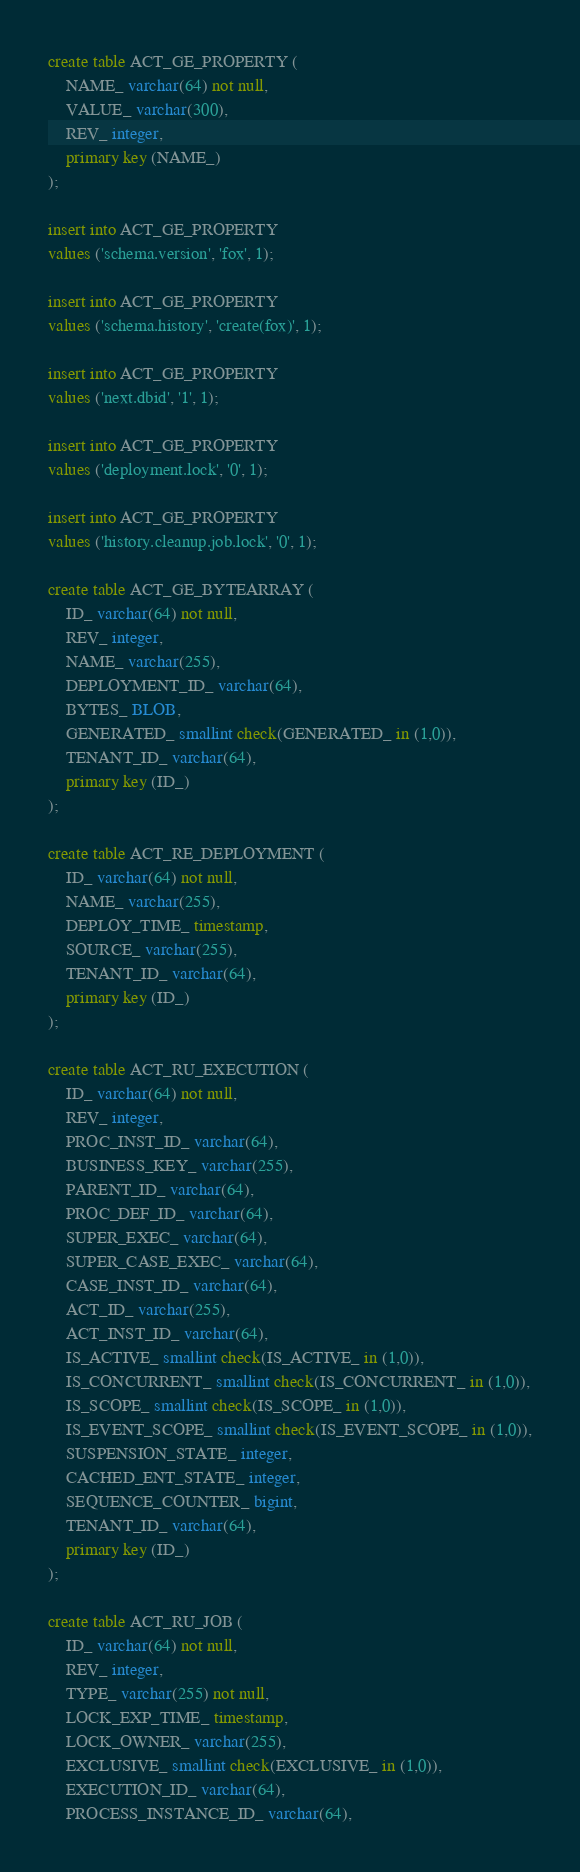Convert code to text. <code><loc_0><loc_0><loc_500><loc_500><_SQL_>create table ACT_GE_PROPERTY (
    NAME_ varchar(64) not null,
    VALUE_ varchar(300),
    REV_ integer,
    primary key (NAME_)
);

insert into ACT_GE_PROPERTY
values ('schema.version', 'fox', 1);

insert into ACT_GE_PROPERTY
values ('schema.history', 'create(fox)', 1);

insert into ACT_GE_PROPERTY
values ('next.dbid', '1', 1);

insert into ACT_GE_PROPERTY
values ('deployment.lock', '0', 1);

insert into ACT_GE_PROPERTY
values ('history.cleanup.job.lock', '0', 1);

create table ACT_GE_BYTEARRAY (
    ID_ varchar(64) not null,
    REV_ integer,
    NAME_ varchar(255),
    DEPLOYMENT_ID_ varchar(64),
    BYTES_ BLOB,
    GENERATED_ smallint check(GENERATED_ in (1,0)),
    TENANT_ID_ varchar(64),
    primary key (ID_)
);

create table ACT_RE_DEPLOYMENT (
    ID_ varchar(64) not null,
    NAME_ varchar(255),
    DEPLOY_TIME_ timestamp,
    SOURCE_ varchar(255),
    TENANT_ID_ varchar(64),
    primary key (ID_)
);

create table ACT_RU_EXECUTION (
    ID_ varchar(64) not null,
    REV_ integer,
    PROC_INST_ID_ varchar(64),
    BUSINESS_KEY_ varchar(255),
    PARENT_ID_ varchar(64),
    PROC_DEF_ID_ varchar(64),
    SUPER_EXEC_ varchar(64),
    SUPER_CASE_EXEC_ varchar(64),
    CASE_INST_ID_ varchar(64),
    ACT_ID_ varchar(255),
    ACT_INST_ID_ varchar(64),
    IS_ACTIVE_ smallint check(IS_ACTIVE_ in (1,0)),
    IS_CONCURRENT_ smallint check(IS_CONCURRENT_ in (1,0)),
    IS_SCOPE_ smallint check(IS_SCOPE_ in (1,0)),
    IS_EVENT_SCOPE_ smallint check(IS_EVENT_SCOPE_ in (1,0)),
    SUSPENSION_STATE_ integer,
    CACHED_ENT_STATE_ integer,
    SEQUENCE_COUNTER_ bigint,
    TENANT_ID_ varchar(64),
    primary key (ID_)
);

create table ACT_RU_JOB (
    ID_ varchar(64) not null,
    REV_ integer,
    TYPE_ varchar(255) not null,
    LOCK_EXP_TIME_ timestamp,
    LOCK_OWNER_ varchar(255),
    EXCLUSIVE_ smallint check(EXCLUSIVE_ in (1,0)),
    EXECUTION_ID_ varchar(64),
    PROCESS_INSTANCE_ID_ varchar(64),</code> 